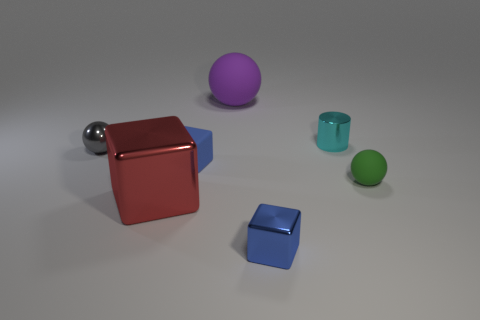What is the shape of the big thing that is behind the small gray thing?
Ensure brevity in your answer.  Sphere. There is a matte sphere that is in front of the small cyan thing; are there any metal cylinders that are in front of it?
Provide a succinct answer. No. Are there any brown matte things of the same size as the green thing?
Keep it short and to the point. No. There is a tiny ball on the left side of the purple ball; is its color the same as the big matte thing?
Offer a very short reply. No. What is the size of the cylinder?
Offer a terse response. Small. There is a ball right of the block in front of the large red shiny block; what is its size?
Keep it short and to the point. Small. How many metal balls are the same color as the tiny metal cylinder?
Your response must be concise. 0. How many large green cylinders are there?
Keep it short and to the point. 0. What number of red things are made of the same material as the big block?
Ensure brevity in your answer.  0. What is the size of the blue metal object that is the same shape as the small blue rubber object?
Your response must be concise. Small. 